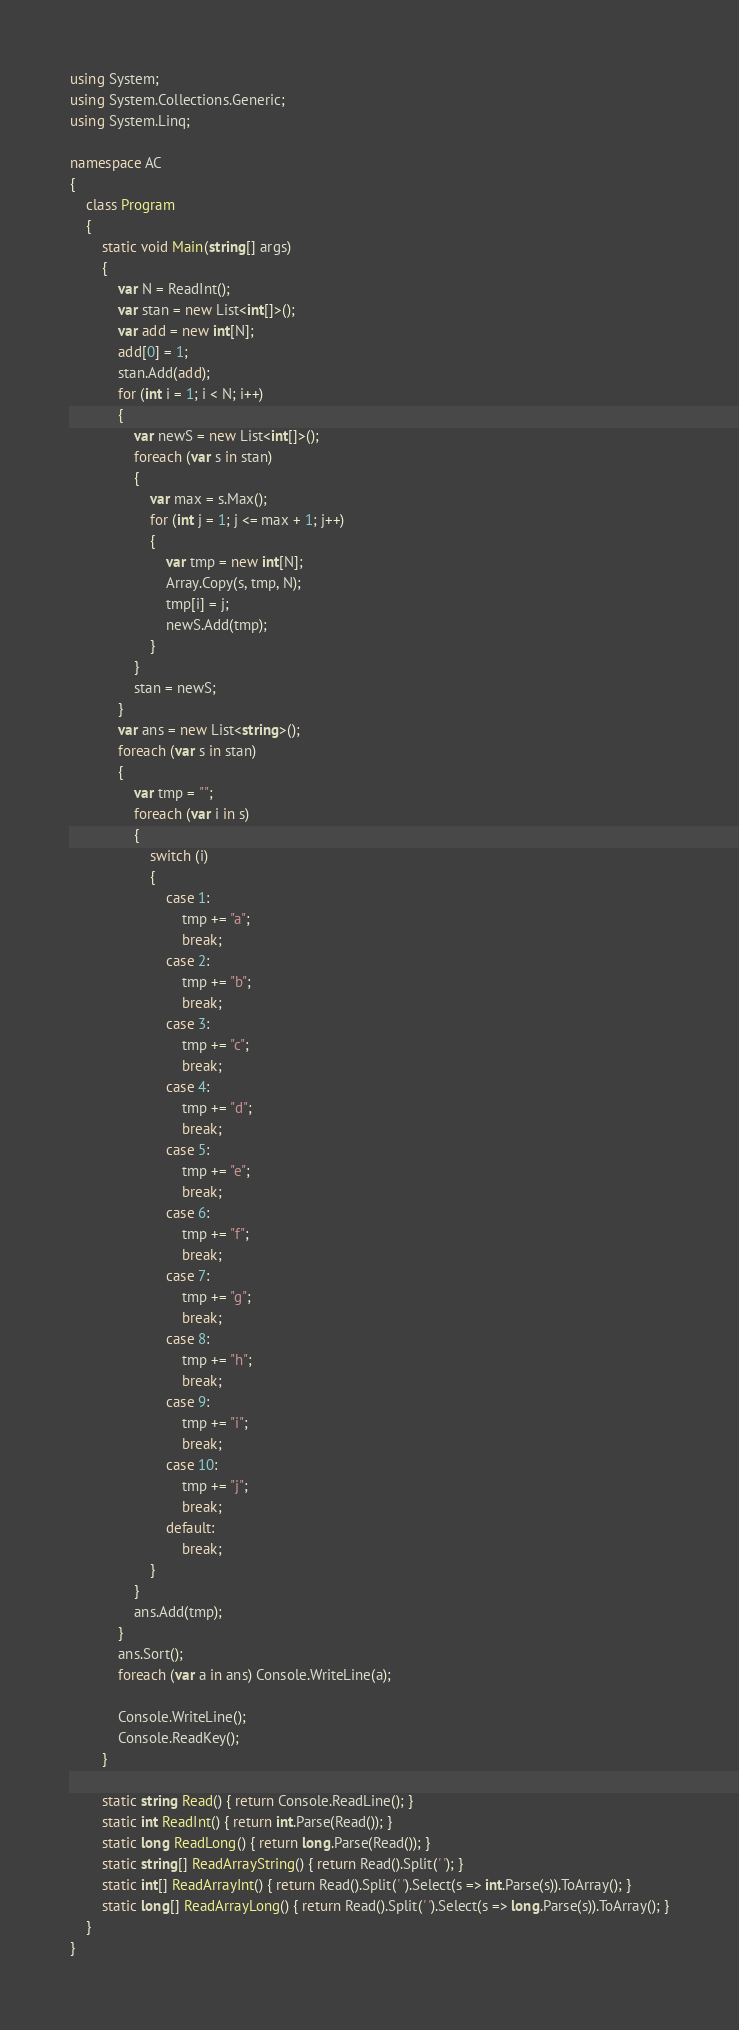<code> <loc_0><loc_0><loc_500><loc_500><_C#_>using System;
using System.Collections.Generic;
using System.Linq;

namespace AC
{
    class Program
    {
        static void Main(string[] args)
        {
            var N = ReadInt();
            var stan = new List<int[]>();
            var add = new int[N];
            add[0] = 1;
            stan.Add(add);
            for (int i = 1; i < N; i++)
            {
                var newS = new List<int[]>();
                foreach (var s in stan)
                {
                    var max = s.Max();
                    for (int j = 1; j <= max + 1; j++)
                    {
                        var tmp = new int[N];
                        Array.Copy(s, tmp, N);
                        tmp[i] = j;
                        newS.Add(tmp);
                    }
                }
                stan = newS;
            }
            var ans = new List<string>();
            foreach (var s in stan)
            {
                var tmp = "";
                foreach (var i in s)
                {
                    switch (i)
                    {
                        case 1:
                            tmp += "a";
                            break;
                        case 2:
                            tmp += "b";
                            break;
                        case 3:
                            tmp += "c";
                            break;
                        case 4:
                            tmp += "d";
                            break;
                        case 5:
                            tmp += "e";
                            break;
                        case 6:
                            tmp += "f";
                            break;
                        case 7:
                            tmp += "g";
                            break;
                        case 8:
                            tmp += "h";
                            break;
                        case 9:
                            tmp += "i";
                            break;
                        case 10:
                            tmp += "j";
                            break;
                        default:
                            break;
                    }
                }
                ans.Add(tmp);
            }
            ans.Sort();
            foreach (var a in ans) Console.WriteLine(a);

            Console.WriteLine();
            Console.ReadKey();
        }

        static string Read() { return Console.ReadLine(); }
        static int ReadInt() { return int.Parse(Read()); }
        static long ReadLong() { return long.Parse(Read()); }
        static string[] ReadArrayString() { return Read().Split(' '); }
        static int[] ReadArrayInt() { return Read().Split(' ').Select(s => int.Parse(s)).ToArray(); }
        static long[] ReadArrayLong() { return Read().Split(' ').Select(s => long.Parse(s)).ToArray(); }
    }
}</code> 